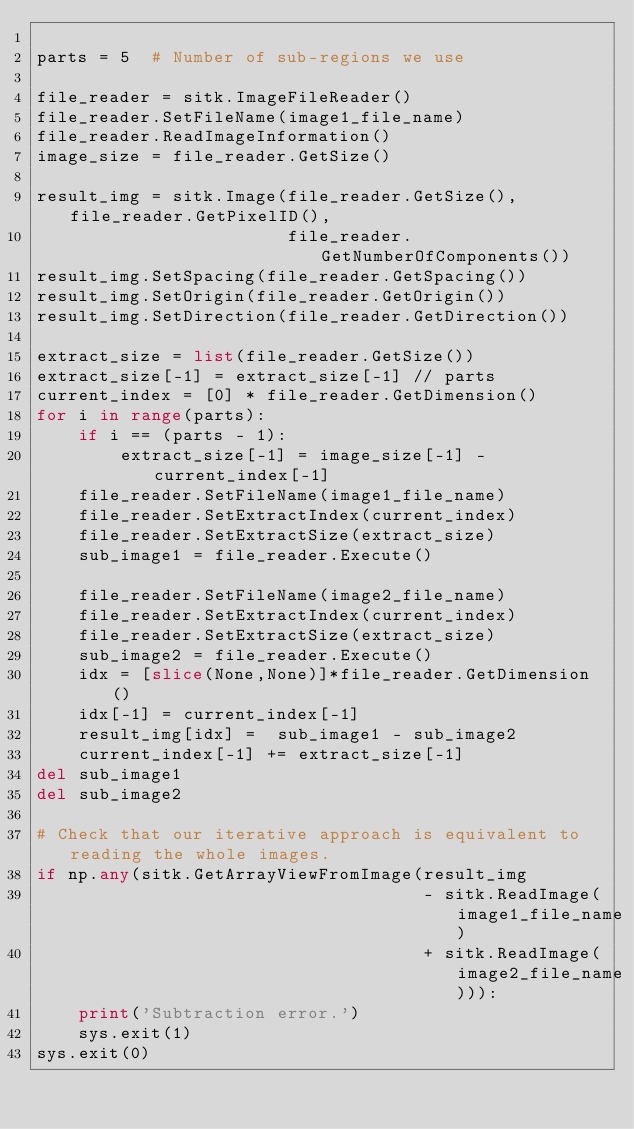Convert code to text. <code><loc_0><loc_0><loc_500><loc_500><_Python_>
parts = 5  # Number of sub-regions we use

file_reader = sitk.ImageFileReader()
file_reader.SetFileName(image1_file_name)
file_reader.ReadImageInformation()
image_size = file_reader.GetSize()

result_img = sitk.Image(file_reader.GetSize(), file_reader.GetPixelID(),
                        file_reader.GetNumberOfComponents())
result_img.SetSpacing(file_reader.GetSpacing())
result_img.SetOrigin(file_reader.GetOrigin())
result_img.SetDirection(file_reader.GetDirection())

extract_size = list(file_reader.GetSize())
extract_size[-1] = extract_size[-1] // parts
current_index = [0] * file_reader.GetDimension()
for i in range(parts):
    if i == (parts - 1):
        extract_size[-1] = image_size[-1] - current_index[-1]
    file_reader.SetFileName(image1_file_name)
    file_reader.SetExtractIndex(current_index)
    file_reader.SetExtractSize(extract_size)
    sub_image1 = file_reader.Execute()

    file_reader.SetFileName(image2_file_name)
    file_reader.SetExtractIndex(current_index)
    file_reader.SetExtractSize(extract_size)
    sub_image2 = file_reader.Execute()
    idx = [slice(None,None)]*file_reader.GetDimension()
    idx[-1] = current_index[-1]
    result_img[idx] =  sub_image1 - sub_image2
    current_index[-1] += extract_size[-1]
del sub_image1
del sub_image2

# Check that our iterative approach is equivalent to reading the whole images.
if np.any(sitk.GetArrayViewFromImage(result_img
                                     - sitk.ReadImage(image1_file_name)
                                     + sitk.ReadImage(image2_file_name))):
    print('Subtraction error.')
    sys.exit(1)
sys.exit(0)
</code> 